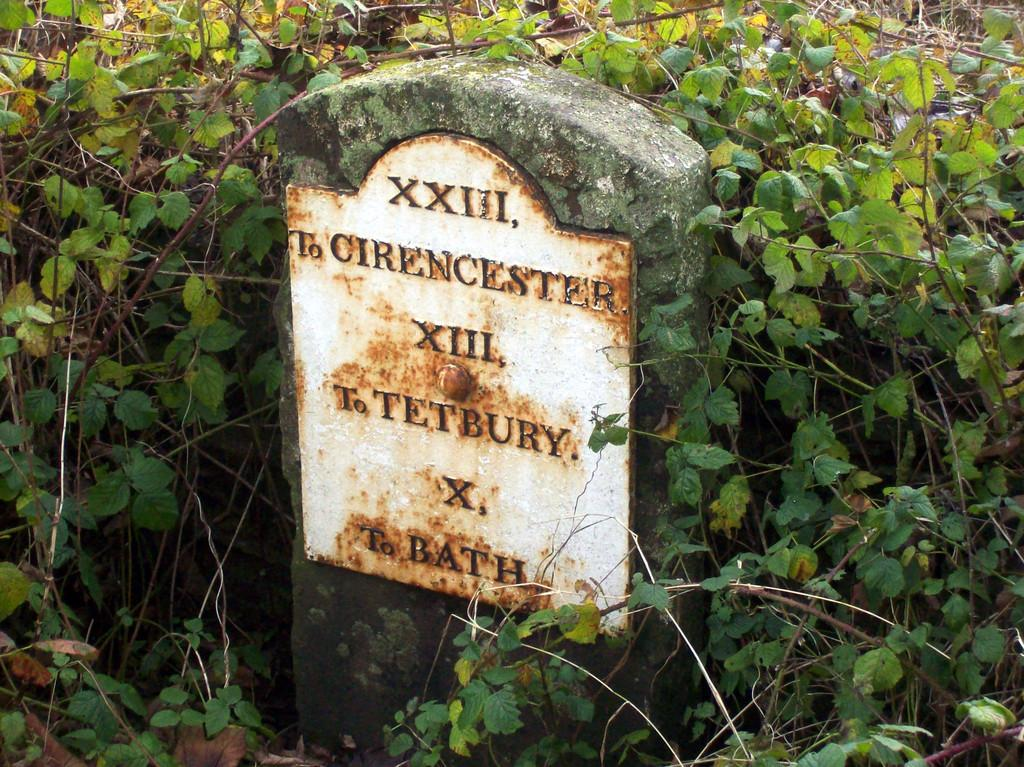What is placed on the stone in the image? There is a board on a stone in the image. What type of natural elements can be seen in the image? There are leaves and stems in the image. What type of ear can be seen in the image? There is no ear present in the image. What type of pancake is being served in the image? There is no pancake present in the image. 